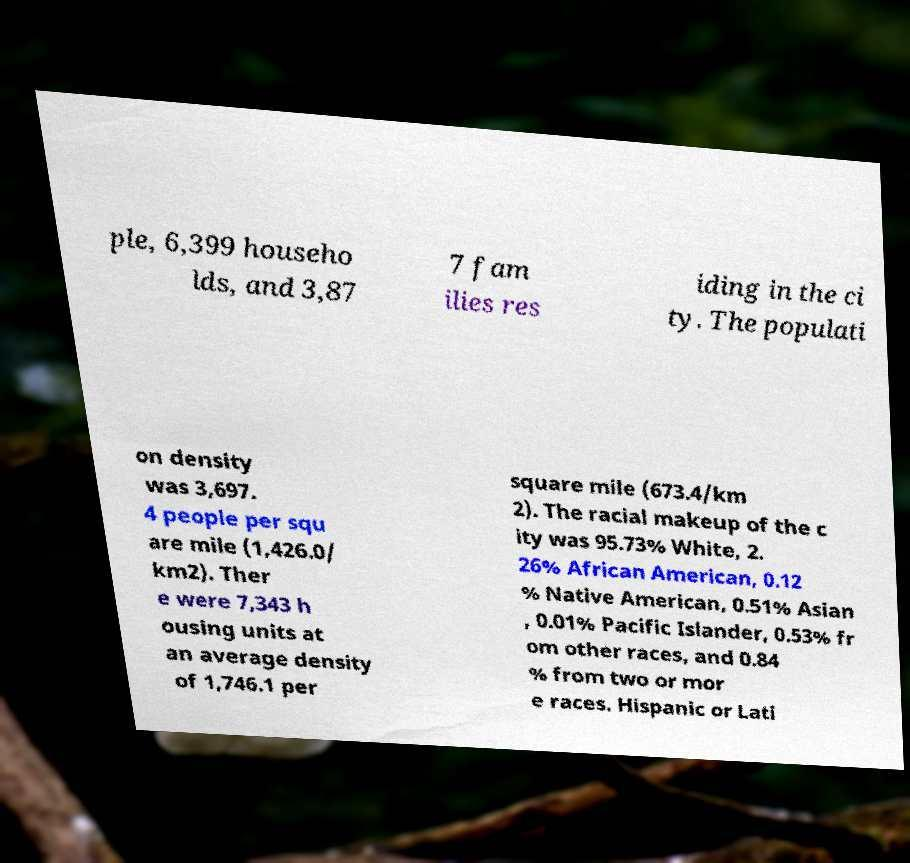I need the written content from this picture converted into text. Can you do that? ple, 6,399 househo lds, and 3,87 7 fam ilies res iding in the ci ty. The populati on density was 3,697. 4 people per squ are mile (1,426.0/ km2). Ther e were 7,343 h ousing units at an average density of 1,746.1 per square mile (673.4/km 2). The racial makeup of the c ity was 95.73% White, 2. 26% African American, 0.12 % Native American, 0.51% Asian , 0.01% Pacific Islander, 0.53% fr om other races, and 0.84 % from two or mor e races. Hispanic or Lati 